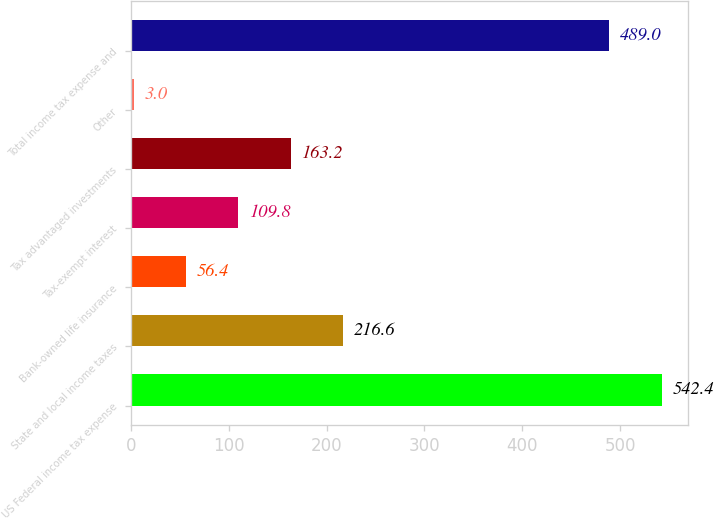<chart> <loc_0><loc_0><loc_500><loc_500><bar_chart><fcel>US Federal income tax expense<fcel>State and local income taxes<fcel>Bank-owned life insurance<fcel>Tax-exempt interest<fcel>Tax advantaged investments<fcel>Other<fcel>Total income tax expense and<nl><fcel>542.4<fcel>216.6<fcel>56.4<fcel>109.8<fcel>163.2<fcel>3<fcel>489<nl></chart> 